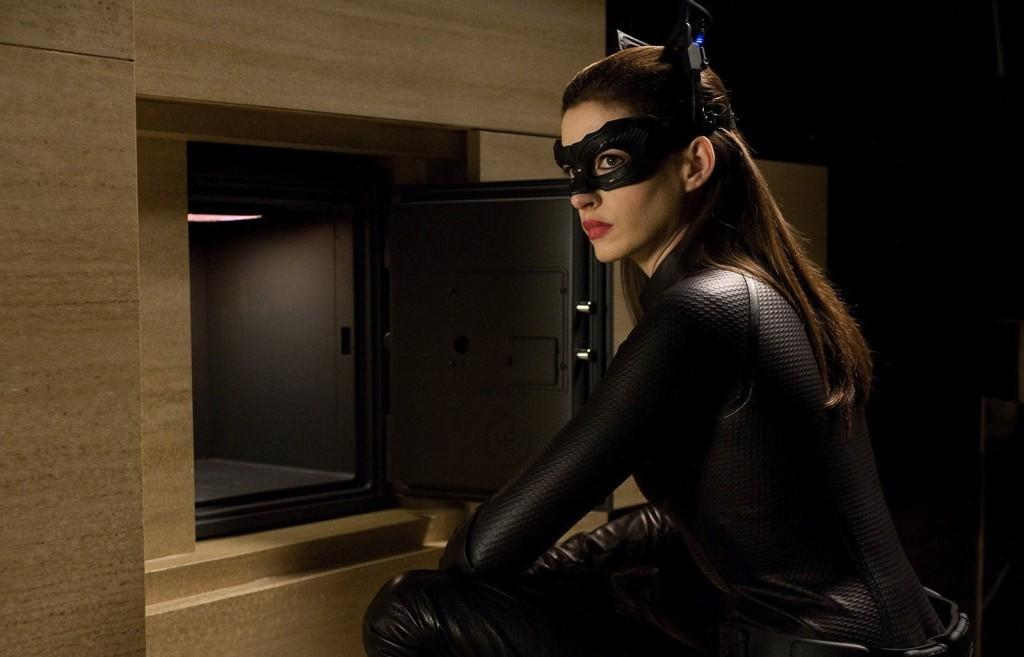Who is present in the image? There is a woman in the image. What is the woman wearing? The woman is wearing a black dress and a mask. What can be seen attached to a wall in the image? There is a locker attached to a wall in the image. What type of sticks are being used by the woman to guide people in the image? There are no sticks or guiding activity present in the image. 